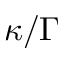<formula> <loc_0><loc_0><loc_500><loc_500>\kappa / \Gamma</formula> 